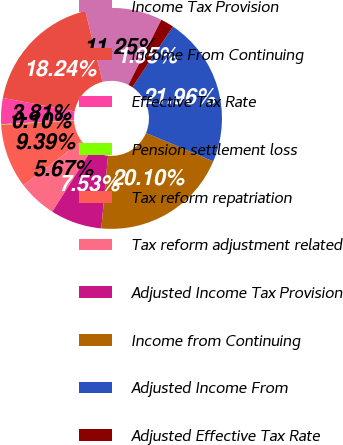Convert chart to OTSL. <chart><loc_0><loc_0><loc_500><loc_500><pie_chart><fcel>Income Tax Provision<fcel>Income From Continuing<fcel>Effective Tax Rate<fcel>Pension settlement loss<fcel>Tax reform repatriation<fcel>Tax reform adjustment related<fcel>Adjusted Income Tax Provision<fcel>Income from Continuing<fcel>Adjusted Income From<fcel>Adjusted Effective Tax Rate<nl><fcel>11.25%<fcel>18.24%<fcel>3.81%<fcel>0.1%<fcel>9.39%<fcel>5.67%<fcel>7.53%<fcel>20.1%<fcel>21.96%<fcel>1.95%<nl></chart> 